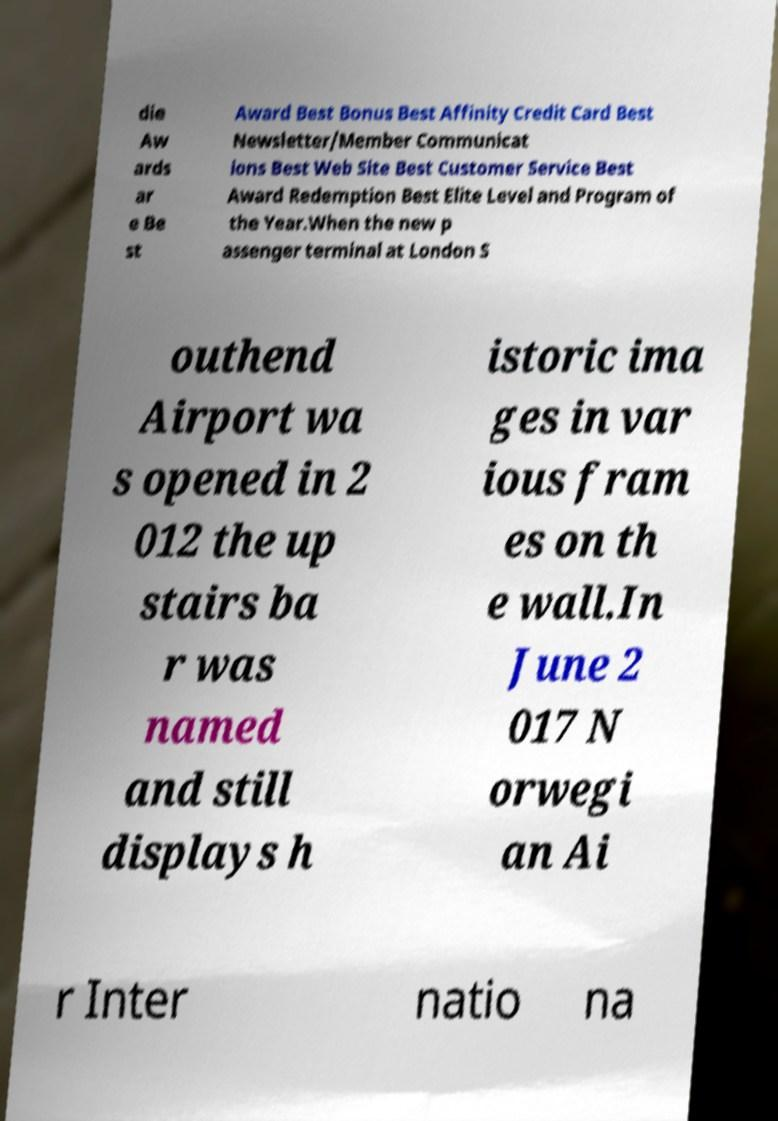Can you accurately transcribe the text from the provided image for me? die Aw ards ar e Be st Award Best Bonus Best Affinity Credit Card Best Newsletter/Member Communicat ions Best Web Site Best Customer Service Best Award Redemption Best Elite Level and Program of the Year.When the new p assenger terminal at London S outhend Airport wa s opened in 2 012 the up stairs ba r was named and still displays h istoric ima ges in var ious fram es on th e wall.In June 2 017 N orwegi an Ai r Inter natio na 